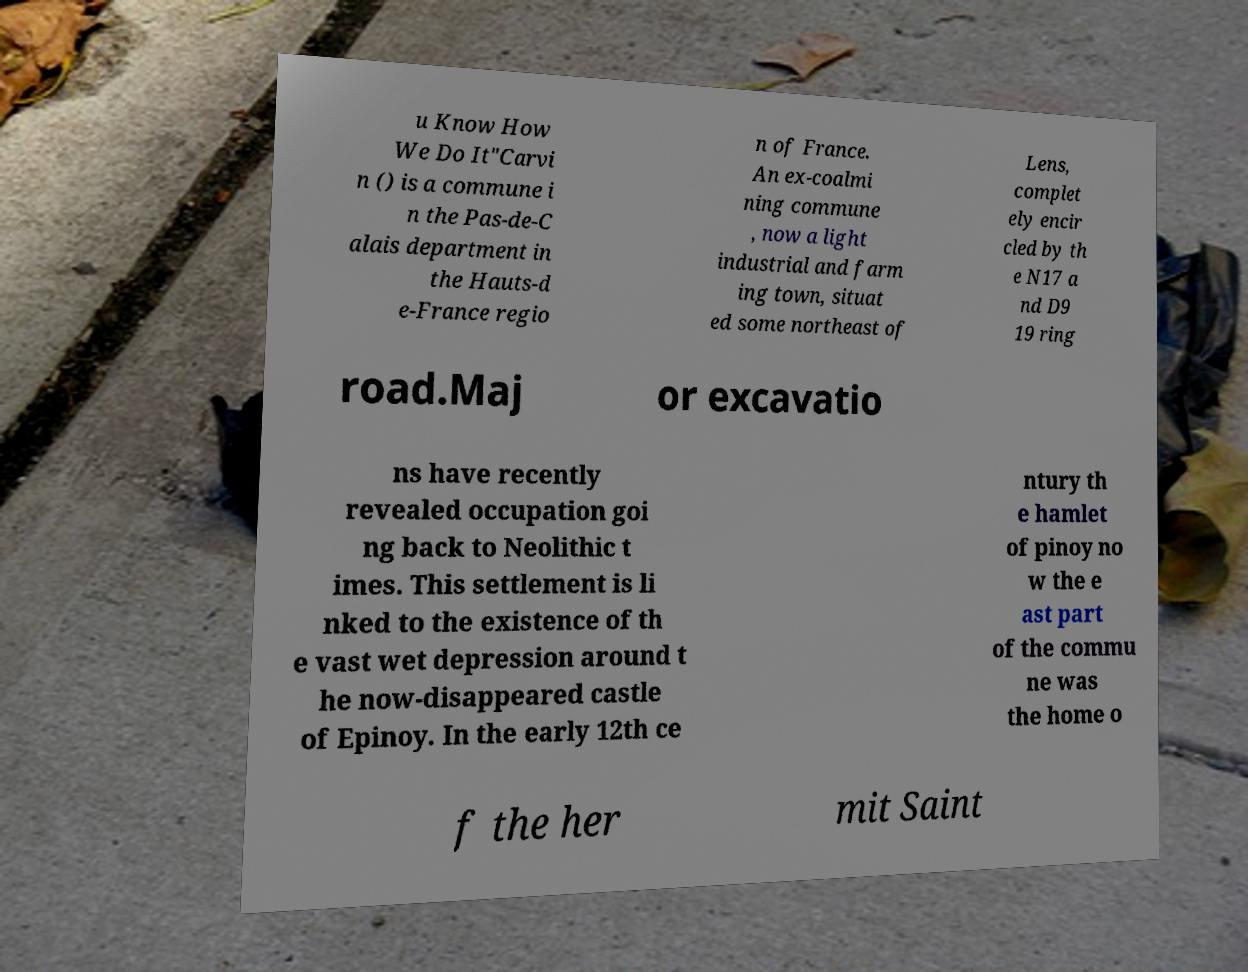There's text embedded in this image that I need extracted. Can you transcribe it verbatim? u Know How We Do It"Carvi n () is a commune i n the Pas-de-C alais department in the Hauts-d e-France regio n of France. An ex-coalmi ning commune , now a light industrial and farm ing town, situat ed some northeast of Lens, complet ely encir cled by th e N17 a nd D9 19 ring road.Maj or excavatio ns have recently revealed occupation goi ng back to Neolithic t imes. This settlement is li nked to the existence of th e vast wet depression around t he now-disappeared castle of Epinoy. In the early 12th ce ntury th e hamlet of pinoy no w the e ast part of the commu ne was the home o f the her mit Saint 